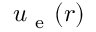Convert formula to latex. <formula><loc_0><loc_0><loc_500><loc_500>u _ { e } ( r )</formula> 